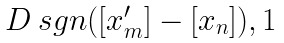Convert formula to latex. <formula><loc_0><loc_0><loc_500><loc_500>\begin{matrix} \ D \ s g n ( [ x ^ { \prime } _ { m } ] - [ x _ { n } ] ) , 1 \end{matrix}</formula> 